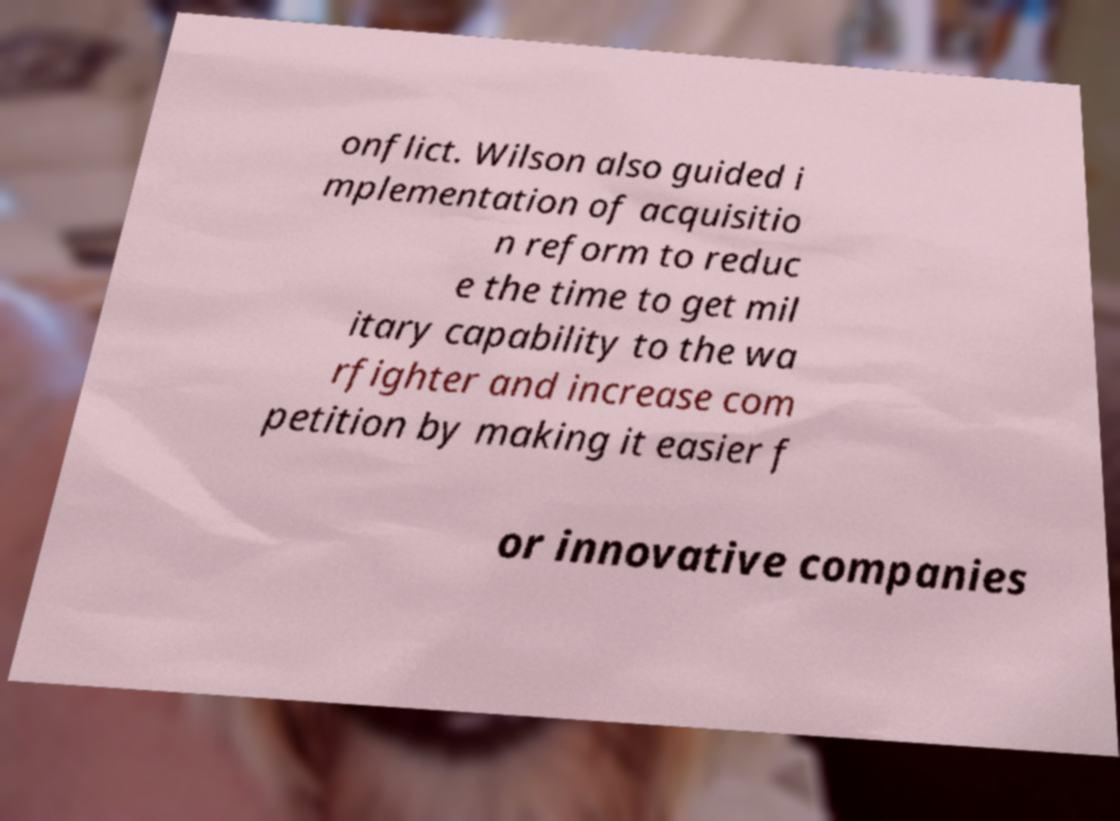Please read and relay the text visible in this image. What does it say? onflict. Wilson also guided i mplementation of acquisitio n reform to reduc e the time to get mil itary capability to the wa rfighter and increase com petition by making it easier f or innovative companies 